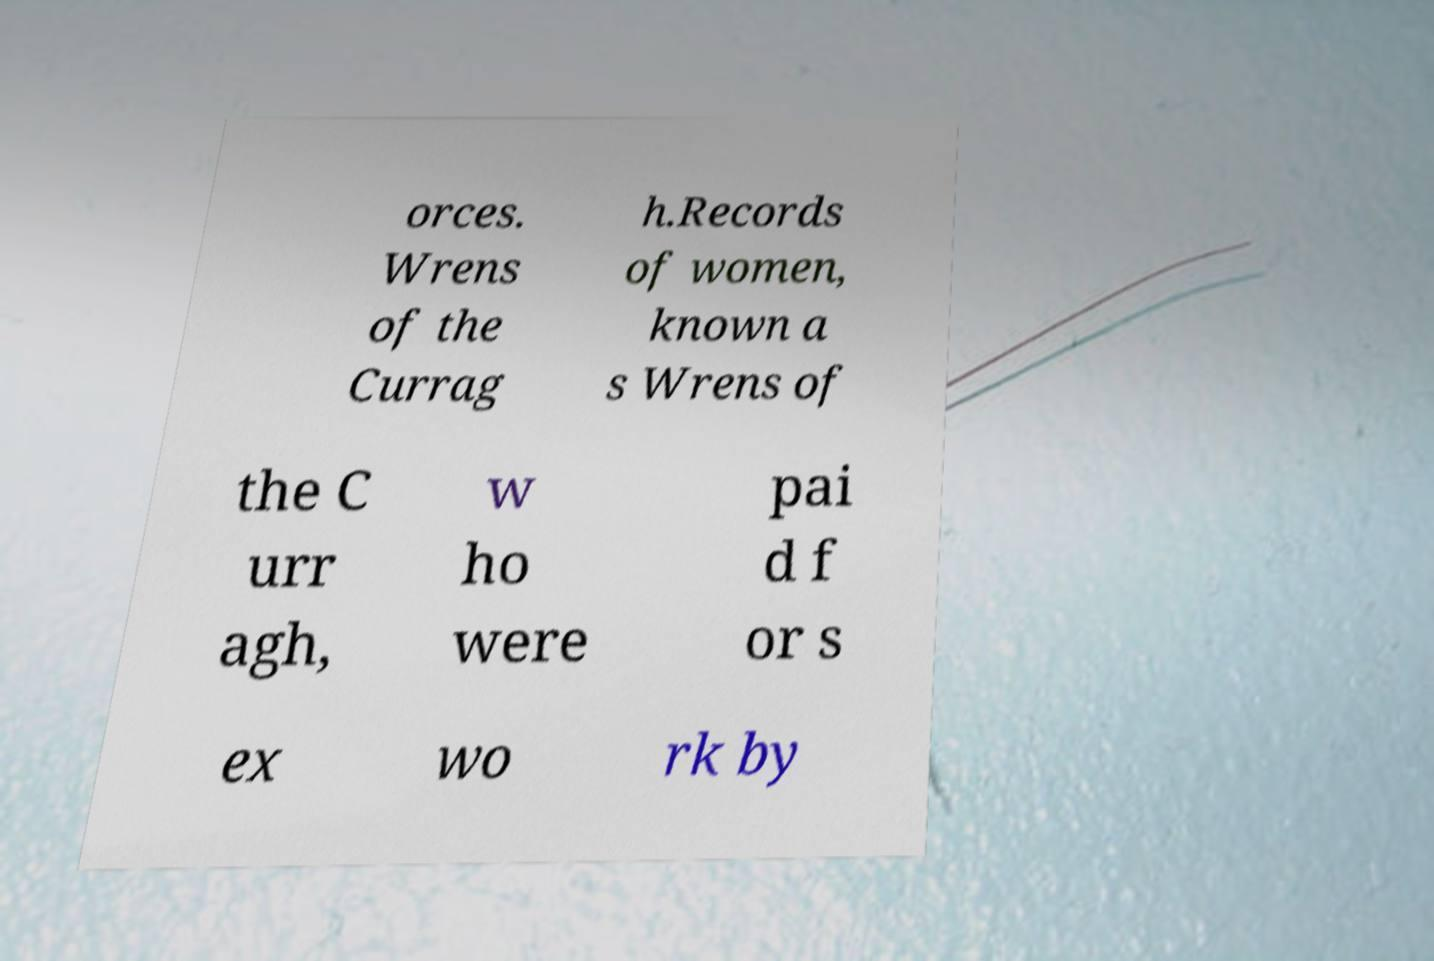Can you accurately transcribe the text from the provided image for me? orces. Wrens of the Currag h.Records of women, known a s Wrens of the C urr agh, w ho were pai d f or s ex wo rk by 